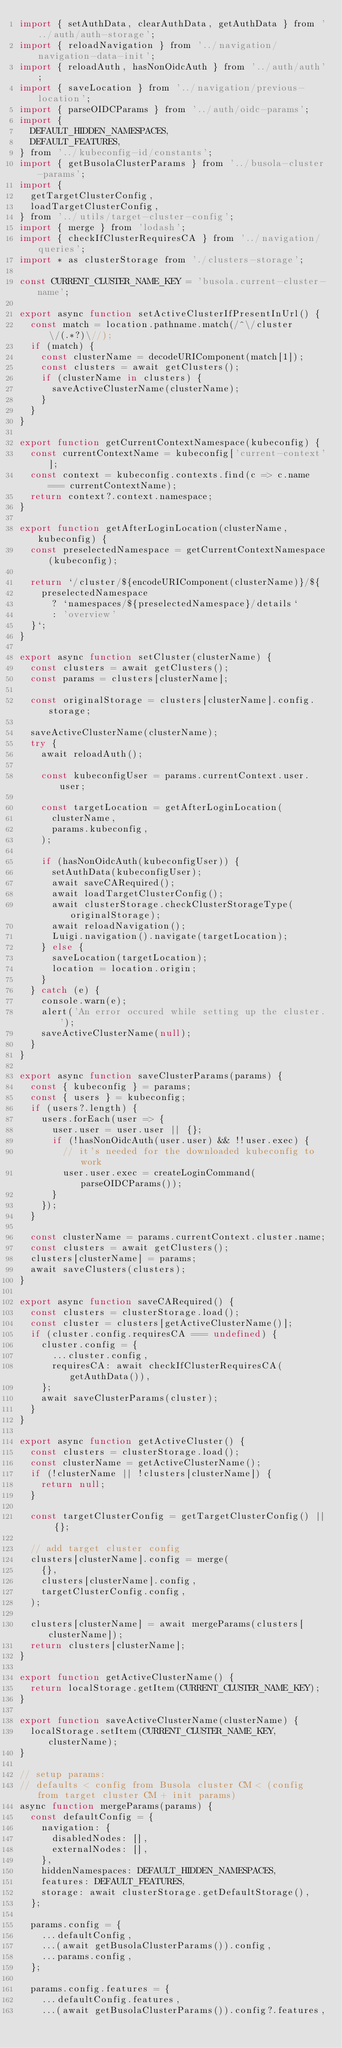Convert code to text. <code><loc_0><loc_0><loc_500><loc_500><_JavaScript_>import { setAuthData, clearAuthData, getAuthData } from '../auth/auth-storage';
import { reloadNavigation } from '../navigation/navigation-data-init';
import { reloadAuth, hasNonOidcAuth } from '../auth/auth';
import { saveLocation } from '../navigation/previous-location';
import { parseOIDCParams } from '../auth/oidc-params';
import {
  DEFAULT_HIDDEN_NAMESPACES,
  DEFAULT_FEATURES,
} from '../kubeconfig-id/constants';
import { getBusolaClusterParams } from '../busola-cluster-params';
import {
  getTargetClusterConfig,
  loadTargetClusterConfig,
} from '../utils/target-cluster-config';
import { merge } from 'lodash';
import { checkIfClusterRequiresCA } from '../navigation/queries';
import * as clusterStorage from './clusters-storage';

const CURRENT_CLUSTER_NAME_KEY = 'busola.current-cluster-name';

export async function setActiveClusterIfPresentInUrl() {
  const match = location.pathname.match(/^\/cluster\/(.*?)\//);
  if (match) {
    const clusterName = decodeURIComponent(match[1]);
    const clusters = await getClusters();
    if (clusterName in clusters) {
      saveActiveClusterName(clusterName);
    }
  }
}

export function getCurrentContextNamespace(kubeconfig) {
  const currentContextName = kubeconfig['current-context'];
  const context = kubeconfig.contexts.find(c => c.name === currentContextName);
  return context?.context.namespace;
}

export function getAfterLoginLocation(clusterName, kubeconfig) {
  const preselectedNamespace = getCurrentContextNamespace(kubeconfig);

  return `/cluster/${encodeURIComponent(clusterName)}/${
    preselectedNamespace
      ? `namespaces/${preselectedNamespace}/details`
      : 'overview'
  }`;
}

export async function setCluster(clusterName) {
  const clusters = await getClusters();
  const params = clusters[clusterName];

  const originalStorage = clusters[clusterName].config.storage;

  saveActiveClusterName(clusterName);
  try {
    await reloadAuth();

    const kubeconfigUser = params.currentContext.user.user;

    const targetLocation = getAfterLoginLocation(
      clusterName,
      params.kubeconfig,
    );

    if (hasNonOidcAuth(kubeconfigUser)) {
      setAuthData(kubeconfigUser);
      await saveCARequired();
      await loadTargetClusterConfig();
      await clusterStorage.checkClusterStorageType(originalStorage);
      await reloadNavigation();
      Luigi.navigation().navigate(targetLocation);
    } else {
      saveLocation(targetLocation);
      location = location.origin;
    }
  } catch (e) {
    console.warn(e);
    alert('An error occured while setting up the cluster.');
    saveActiveClusterName(null);
  }
}

export async function saveClusterParams(params) {
  const { kubeconfig } = params;
  const { users } = kubeconfig;
  if (users?.length) {
    users.forEach(user => {
      user.user = user.user || {};
      if (!hasNonOidcAuth(user.user) && !!user.exec) {
        // it's needed for the downloaded kubeconfig to work
        user.user.exec = createLoginCommand(parseOIDCParams());
      }
    });
  }

  const clusterName = params.currentContext.cluster.name;
  const clusters = await getClusters();
  clusters[clusterName] = params;
  await saveClusters(clusters);
}

export async function saveCARequired() {
  const clusters = clusterStorage.load();
  const cluster = clusters[getActiveClusterName()];
  if (cluster.config.requiresCA === undefined) {
    cluster.config = {
      ...cluster.config,
      requiresCA: await checkIfClusterRequiresCA(getAuthData()),
    };
    await saveClusterParams(cluster);
  }
}

export async function getActiveCluster() {
  const clusters = clusterStorage.load();
  const clusterName = getActiveClusterName();
  if (!clusterName || !clusters[clusterName]) {
    return null;
  }

  const targetClusterConfig = getTargetClusterConfig() || {};

  // add target cluster config
  clusters[clusterName].config = merge(
    {},
    clusters[clusterName].config,
    targetClusterConfig.config,
  );

  clusters[clusterName] = await mergeParams(clusters[clusterName]);
  return clusters[clusterName];
}

export function getActiveClusterName() {
  return localStorage.getItem(CURRENT_CLUSTER_NAME_KEY);
}

export function saveActiveClusterName(clusterName) {
  localStorage.setItem(CURRENT_CLUSTER_NAME_KEY, clusterName);
}

// setup params:
// defaults < config from Busola cluster CM < (config from target cluster CM + init params)
async function mergeParams(params) {
  const defaultConfig = {
    navigation: {
      disabledNodes: [],
      externalNodes: [],
    },
    hiddenNamespaces: DEFAULT_HIDDEN_NAMESPACES,
    features: DEFAULT_FEATURES,
    storage: await clusterStorage.getDefaultStorage(),
  };

  params.config = {
    ...defaultConfig,
    ...(await getBusolaClusterParams()).config,
    ...params.config,
  };

  params.config.features = {
    ...defaultConfig.features,
    ...(await getBusolaClusterParams()).config?.features,</code> 